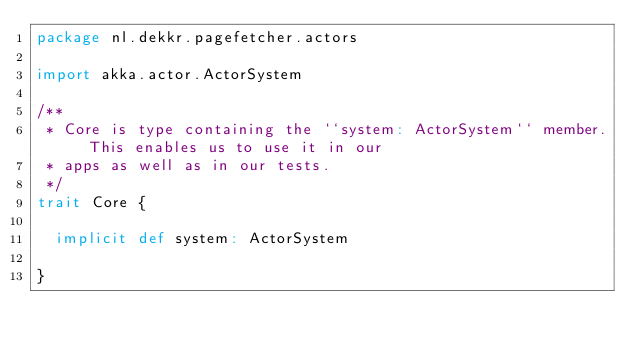Convert code to text. <code><loc_0><loc_0><loc_500><loc_500><_Scala_>package nl.dekkr.pagefetcher.actors

import akka.actor.ActorSystem

/**
 * Core is type containing the ``system: ActorSystem`` member. This enables us to use it in our
 * apps as well as in our tests.
 */
trait Core {

  implicit def system: ActorSystem

}
</code> 